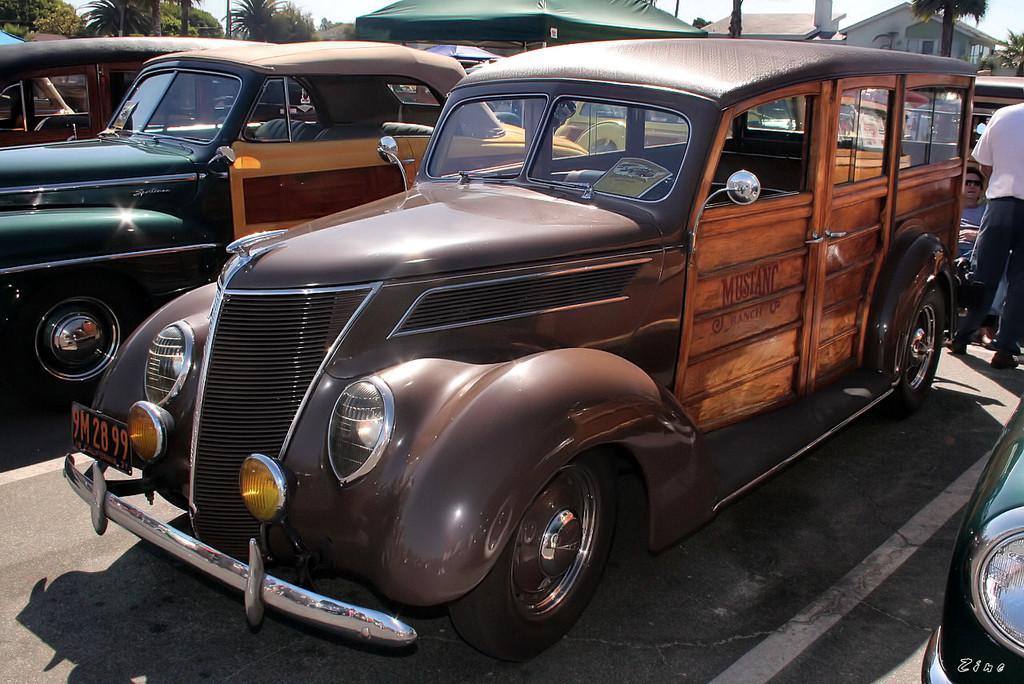Can you describe this image briefly? In this picture we can see a few vehicles on the path. Two people are visible on the right side. There is a tent. We can see a text in the bottom right. There are a few trees and houses in the background. 